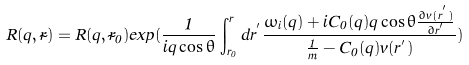Convert formula to latex. <formula><loc_0><loc_0><loc_500><loc_500>R ( { q } , { \vec { r } } ) = R ( { q } , { \vec { r } } _ { 0 } ) e x p ( \frac { 1 } { i q \cos \theta } \int ^ { r } _ { r _ { 0 } } d r ^ { ^ { \prime } } \frac { \omega _ { i } ( { q } ) + i C _ { 0 } ( { q } ) q \cos \theta \frac { \partial v ( r ^ { ^ { \prime } } ) } { \partial r ^ { ^ { \prime } } } } { \frac { 1 } { m } - C _ { 0 } ( { q } ) v ( r ^ { ^ { \prime } } ) } )</formula> 